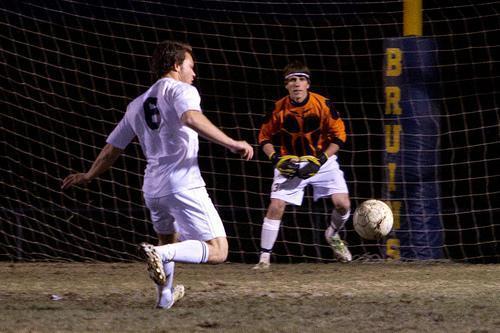How many men are in the image?
Give a very brief answer. 2. 